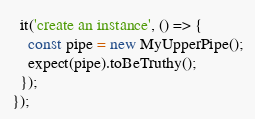<code> <loc_0><loc_0><loc_500><loc_500><_TypeScript_>  it('create an instance', () => {
    const pipe = new MyUpperPipe();
    expect(pipe).toBeTruthy();
  });
});
</code> 